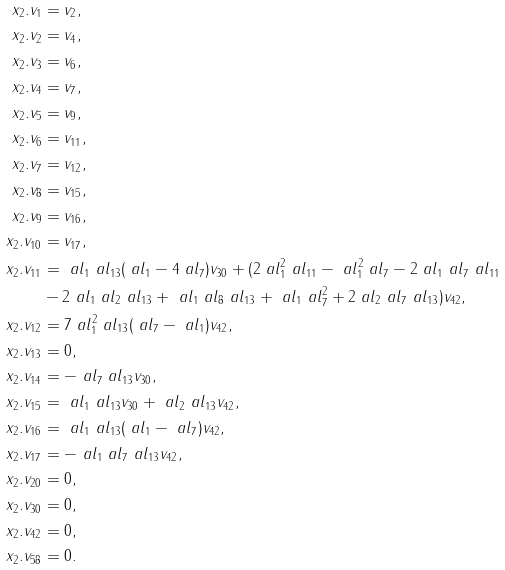<formula> <loc_0><loc_0><loc_500><loc_500>x _ { 2 } . v _ { 1 } & = v _ { 2 } , \\ x _ { 2 } . v _ { 2 } & = v _ { 4 } , \\ x _ { 2 } . v _ { 3 } & = v _ { 6 } , \\ x _ { 2 } . v _ { 4 } & = v _ { 7 } , \\ x _ { 2 } . v _ { 5 } & = v _ { 9 } , \\ x _ { 2 } . v _ { 6 } & = v _ { 1 1 } , \\ x _ { 2 } . v _ { 7 } & = v _ { 1 2 } , \\ x _ { 2 } . v _ { 8 } & = v _ { 1 5 } , \\ x _ { 2 } . v _ { 9 } & = v _ { 1 6 } , \\ x _ { 2 } . v _ { 1 0 } & = v _ { 1 7 } , \\ x _ { 2 } . v _ { 1 1 } & = \ a l _ { 1 } \ a l _ { 1 3 } ( \ a l _ { 1 } - 4 \ a l _ { 7 } ) v _ { 3 0 } + ( 2 \ a l _ { 1 } ^ { 2 } \ a l _ { 1 1 } - \ a l _ { 1 } ^ { 2 } \ a l _ { 7 } - 2 \ a l _ { 1 } \ a l _ { 7 } \ a l _ { 1 1 } \\ & - 2 \ a l _ { 1 } \ a l _ { 2 } \ a l _ { 1 3 } + \ a l _ { 1 } \ a l _ { 8 } \ a l _ { 1 3 } + \ a l _ { 1 } \ a l _ { 7 } ^ { 2 } + 2 \ a l _ { 2 } \ a l _ { 7 } \ a l _ { 1 3 } ) v _ { 4 2 } , \\ x _ { 2 } . v _ { 1 2 } & = 7 \ a l _ { 1 } ^ { 2 } \ a l _ { 1 3 } ( \ a l _ { 7 } - \ a l _ { 1 } ) v _ { 4 2 } , \\ x _ { 2 } . v _ { 1 3 } & = 0 , \\ x _ { 2 } . v _ { 1 4 } & = - \ a l _ { 7 } \ a l _ { 1 3 } v _ { 3 0 } , \\ x _ { 2 } . v _ { 1 5 } & = \ a l _ { 1 } \ a l _ { 1 3 } v _ { 3 0 } + \ a l _ { 2 } \ a l _ { 1 3 } v _ { 4 2 } , \\ x _ { 2 } . v _ { 1 6 } & = \ a l _ { 1 } \ a l _ { 1 3 } ( \ a l _ { 1 } - \ a l _ { 7 } ) v _ { 4 2 } , \\ x _ { 2 } . v _ { 1 7 } & = - \ a l _ { 1 } \ a l _ { 7 } \ a l _ { 1 3 } v _ { 4 2 } , \\ x _ { 2 } . v _ { 2 0 } & = 0 , \\ x _ { 2 } . v _ { 3 0 } & = 0 , \\ x _ { 2 } . v _ { 4 2 } & = 0 , \\ x _ { 2 } . v _ { 5 8 } & = 0 .</formula> 